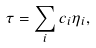<formula> <loc_0><loc_0><loc_500><loc_500>\tau = \sum _ { i } c _ { i } \eta _ { i } ,</formula> 